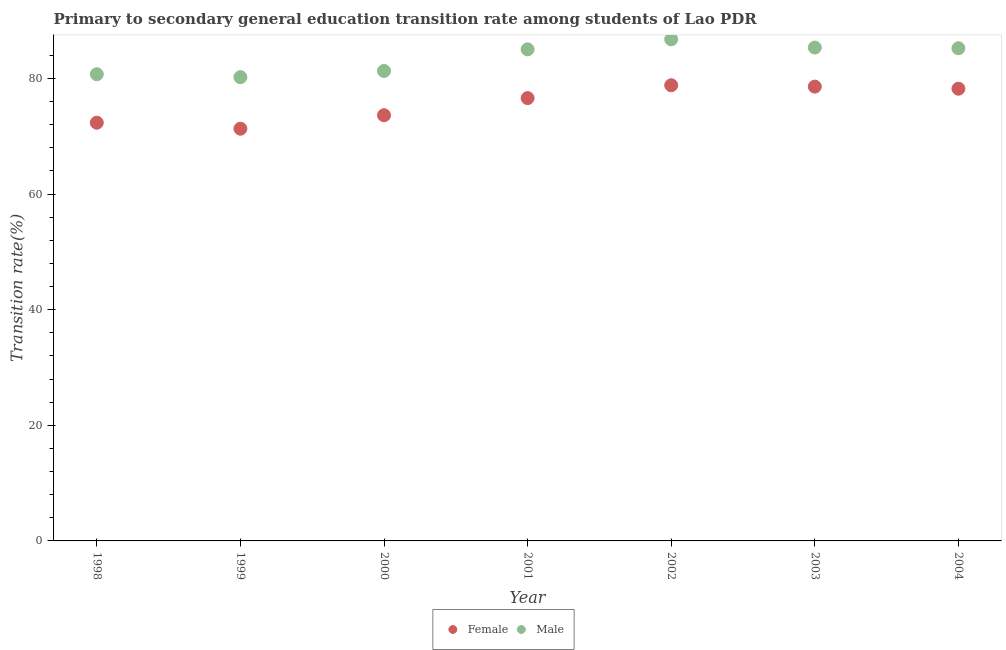Is the number of dotlines equal to the number of legend labels?
Offer a terse response. Yes. What is the transition rate among female students in 2001?
Your response must be concise. 76.6. Across all years, what is the maximum transition rate among male students?
Offer a very short reply. 86.76. Across all years, what is the minimum transition rate among male students?
Your answer should be compact. 80.22. What is the total transition rate among female students in the graph?
Offer a very short reply. 529.49. What is the difference between the transition rate among female students in 1999 and that in 2003?
Offer a terse response. -7.28. What is the difference between the transition rate among female students in 2000 and the transition rate among male students in 2004?
Your response must be concise. -11.59. What is the average transition rate among male students per year?
Your answer should be very brief. 83.51. In the year 2003, what is the difference between the transition rate among male students and transition rate among female students?
Provide a short and direct response. 6.76. In how many years, is the transition rate among male students greater than 48 %?
Make the answer very short. 7. What is the ratio of the transition rate among female students in 2001 to that in 2004?
Provide a succinct answer. 0.98. Is the transition rate among female students in 1998 less than that in 2002?
Your answer should be very brief. Yes. Is the difference between the transition rate among female students in 1998 and 2000 greater than the difference between the transition rate among male students in 1998 and 2000?
Your answer should be compact. No. What is the difference between the highest and the second highest transition rate among female students?
Provide a short and direct response. 0.24. What is the difference between the highest and the lowest transition rate among male students?
Offer a very short reply. 6.54. Is the sum of the transition rate among female students in 2001 and 2002 greater than the maximum transition rate among male students across all years?
Offer a very short reply. Yes. Is the transition rate among male students strictly less than the transition rate among female students over the years?
Ensure brevity in your answer.  No. How many dotlines are there?
Your response must be concise. 2. How many years are there in the graph?
Give a very brief answer. 7. What is the difference between two consecutive major ticks on the Y-axis?
Your response must be concise. 20. Does the graph contain grids?
Provide a succinct answer. No. Where does the legend appear in the graph?
Give a very brief answer. Bottom center. What is the title of the graph?
Your response must be concise. Primary to secondary general education transition rate among students of Lao PDR. Does "Diarrhea" appear as one of the legend labels in the graph?
Ensure brevity in your answer.  No. What is the label or title of the Y-axis?
Offer a very short reply. Transition rate(%). What is the Transition rate(%) of Female in 1998?
Make the answer very short. 72.34. What is the Transition rate(%) in Male in 1998?
Your answer should be very brief. 80.72. What is the Transition rate(%) of Female in 1999?
Offer a very short reply. 71.3. What is the Transition rate(%) in Male in 1999?
Keep it short and to the point. 80.22. What is the Transition rate(%) of Female in 2000?
Keep it short and to the point. 73.63. What is the Transition rate(%) in Male in 2000?
Make the answer very short. 81.3. What is the Transition rate(%) in Female in 2001?
Offer a terse response. 76.6. What is the Transition rate(%) in Male in 2001?
Keep it short and to the point. 85.03. What is the Transition rate(%) of Female in 2002?
Your answer should be very brief. 78.82. What is the Transition rate(%) in Male in 2002?
Offer a terse response. 86.76. What is the Transition rate(%) in Female in 2003?
Your answer should be compact. 78.58. What is the Transition rate(%) of Male in 2003?
Make the answer very short. 85.34. What is the Transition rate(%) in Female in 2004?
Give a very brief answer. 78.22. What is the Transition rate(%) of Male in 2004?
Keep it short and to the point. 85.22. Across all years, what is the maximum Transition rate(%) of Female?
Your answer should be very brief. 78.82. Across all years, what is the maximum Transition rate(%) of Male?
Your answer should be compact. 86.76. Across all years, what is the minimum Transition rate(%) of Female?
Your answer should be very brief. 71.3. Across all years, what is the minimum Transition rate(%) in Male?
Ensure brevity in your answer.  80.22. What is the total Transition rate(%) in Female in the graph?
Keep it short and to the point. 529.49. What is the total Transition rate(%) of Male in the graph?
Your response must be concise. 584.58. What is the difference between the Transition rate(%) of Female in 1998 and that in 1999?
Your answer should be compact. 1.04. What is the difference between the Transition rate(%) in Male in 1998 and that in 1999?
Your answer should be compact. 0.51. What is the difference between the Transition rate(%) in Female in 1998 and that in 2000?
Your answer should be very brief. -1.29. What is the difference between the Transition rate(%) of Male in 1998 and that in 2000?
Make the answer very short. -0.57. What is the difference between the Transition rate(%) of Female in 1998 and that in 2001?
Your answer should be compact. -4.26. What is the difference between the Transition rate(%) of Male in 1998 and that in 2001?
Provide a succinct answer. -4.3. What is the difference between the Transition rate(%) in Female in 1998 and that in 2002?
Your response must be concise. -6.48. What is the difference between the Transition rate(%) of Male in 1998 and that in 2002?
Your response must be concise. -6.03. What is the difference between the Transition rate(%) of Female in 1998 and that in 2003?
Ensure brevity in your answer.  -6.25. What is the difference between the Transition rate(%) in Male in 1998 and that in 2003?
Your response must be concise. -4.61. What is the difference between the Transition rate(%) of Female in 1998 and that in 2004?
Keep it short and to the point. -5.88. What is the difference between the Transition rate(%) of Male in 1998 and that in 2004?
Your response must be concise. -4.5. What is the difference between the Transition rate(%) in Female in 1999 and that in 2000?
Your answer should be very brief. -2.33. What is the difference between the Transition rate(%) in Male in 1999 and that in 2000?
Your response must be concise. -1.08. What is the difference between the Transition rate(%) of Female in 1999 and that in 2001?
Provide a succinct answer. -5.3. What is the difference between the Transition rate(%) in Male in 1999 and that in 2001?
Your answer should be very brief. -4.81. What is the difference between the Transition rate(%) in Female in 1999 and that in 2002?
Your answer should be compact. -7.52. What is the difference between the Transition rate(%) of Male in 1999 and that in 2002?
Offer a very short reply. -6.54. What is the difference between the Transition rate(%) of Female in 1999 and that in 2003?
Your answer should be very brief. -7.28. What is the difference between the Transition rate(%) in Male in 1999 and that in 2003?
Make the answer very short. -5.12. What is the difference between the Transition rate(%) of Female in 1999 and that in 2004?
Ensure brevity in your answer.  -6.92. What is the difference between the Transition rate(%) in Male in 1999 and that in 2004?
Your answer should be compact. -5. What is the difference between the Transition rate(%) of Female in 2000 and that in 2001?
Provide a succinct answer. -2.97. What is the difference between the Transition rate(%) in Male in 2000 and that in 2001?
Your response must be concise. -3.73. What is the difference between the Transition rate(%) in Female in 2000 and that in 2002?
Give a very brief answer. -5.19. What is the difference between the Transition rate(%) in Male in 2000 and that in 2002?
Provide a short and direct response. -5.46. What is the difference between the Transition rate(%) in Female in 2000 and that in 2003?
Keep it short and to the point. -4.95. What is the difference between the Transition rate(%) of Male in 2000 and that in 2003?
Give a very brief answer. -4.04. What is the difference between the Transition rate(%) in Female in 2000 and that in 2004?
Provide a succinct answer. -4.59. What is the difference between the Transition rate(%) of Male in 2000 and that in 2004?
Ensure brevity in your answer.  -3.92. What is the difference between the Transition rate(%) in Female in 2001 and that in 2002?
Your response must be concise. -2.22. What is the difference between the Transition rate(%) in Male in 2001 and that in 2002?
Offer a terse response. -1.73. What is the difference between the Transition rate(%) in Female in 2001 and that in 2003?
Your response must be concise. -1.99. What is the difference between the Transition rate(%) in Male in 2001 and that in 2003?
Offer a very short reply. -0.31. What is the difference between the Transition rate(%) in Female in 2001 and that in 2004?
Your answer should be compact. -1.62. What is the difference between the Transition rate(%) of Male in 2001 and that in 2004?
Your response must be concise. -0.19. What is the difference between the Transition rate(%) of Female in 2002 and that in 2003?
Offer a terse response. 0.24. What is the difference between the Transition rate(%) in Male in 2002 and that in 2003?
Provide a short and direct response. 1.42. What is the difference between the Transition rate(%) in Female in 2002 and that in 2004?
Your response must be concise. 0.6. What is the difference between the Transition rate(%) in Male in 2002 and that in 2004?
Offer a terse response. 1.54. What is the difference between the Transition rate(%) of Female in 2003 and that in 2004?
Your answer should be compact. 0.36. What is the difference between the Transition rate(%) in Male in 2003 and that in 2004?
Offer a terse response. 0.12. What is the difference between the Transition rate(%) of Female in 1998 and the Transition rate(%) of Male in 1999?
Your response must be concise. -7.88. What is the difference between the Transition rate(%) in Female in 1998 and the Transition rate(%) in Male in 2000?
Keep it short and to the point. -8.96. What is the difference between the Transition rate(%) in Female in 1998 and the Transition rate(%) in Male in 2001?
Provide a succinct answer. -12.69. What is the difference between the Transition rate(%) of Female in 1998 and the Transition rate(%) of Male in 2002?
Provide a succinct answer. -14.42. What is the difference between the Transition rate(%) of Female in 1998 and the Transition rate(%) of Male in 2003?
Offer a terse response. -13. What is the difference between the Transition rate(%) of Female in 1998 and the Transition rate(%) of Male in 2004?
Your answer should be very brief. -12.88. What is the difference between the Transition rate(%) in Female in 1999 and the Transition rate(%) in Male in 2000?
Offer a very short reply. -10. What is the difference between the Transition rate(%) in Female in 1999 and the Transition rate(%) in Male in 2001?
Provide a short and direct response. -13.73. What is the difference between the Transition rate(%) of Female in 1999 and the Transition rate(%) of Male in 2002?
Provide a short and direct response. -15.46. What is the difference between the Transition rate(%) of Female in 1999 and the Transition rate(%) of Male in 2003?
Make the answer very short. -14.04. What is the difference between the Transition rate(%) in Female in 1999 and the Transition rate(%) in Male in 2004?
Provide a succinct answer. -13.92. What is the difference between the Transition rate(%) in Female in 2000 and the Transition rate(%) in Male in 2001?
Offer a very short reply. -11.4. What is the difference between the Transition rate(%) in Female in 2000 and the Transition rate(%) in Male in 2002?
Your answer should be very brief. -13.13. What is the difference between the Transition rate(%) of Female in 2000 and the Transition rate(%) of Male in 2003?
Your answer should be very brief. -11.71. What is the difference between the Transition rate(%) of Female in 2000 and the Transition rate(%) of Male in 2004?
Keep it short and to the point. -11.59. What is the difference between the Transition rate(%) in Female in 2001 and the Transition rate(%) in Male in 2002?
Provide a short and direct response. -10.16. What is the difference between the Transition rate(%) in Female in 2001 and the Transition rate(%) in Male in 2003?
Keep it short and to the point. -8.74. What is the difference between the Transition rate(%) in Female in 2001 and the Transition rate(%) in Male in 2004?
Your answer should be compact. -8.62. What is the difference between the Transition rate(%) in Female in 2002 and the Transition rate(%) in Male in 2003?
Provide a short and direct response. -6.52. What is the difference between the Transition rate(%) of Female in 2002 and the Transition rate(%) of Male in 2004?
Ensure brevity in your answer.  -6.4. What is the difference between the Transition rate(%) in Female in 2003 and the Transition rate(%) in Male in 2004?
Ensure brevity in your answer.  -6.64. What is the average Transition rate(%) of Female per year?
Provide a succinct answer. 75.64. What is the average Transition rate(%) of Male per year?
Your response must be concise. 83.51. In the year 1998, what is the difference between the Transition rate(%) of Female and Transition rate(%) of Male?
Keep it short and to the point. -8.39. In the year 1999, what is the difference between the Transition rate(%) of Female and Transition rate(%) of Male?
Offer a very short reply. -8.92. In the year 2000, what is the difference between the Transition rate(%) of Female and Transition rate(%) of Male?
Offer a terse response. -7.66. In the year 2001, what is the difference between the Transition rate(%) of Female and Transition rate(%) of Male?
Your response must be concise. -8.43. In the year 2002, what is the difference between the Transition rate(%) of Female and Transition rate(%) of Male?
Keep it short and to the point. -7.94. In the year 2003, what is the difference between the Transition rate(%) of Female and Transition rate(%) of Male?
Your answer should be compact. -6.76. In the year 2004, what is the difference between the Transition rate(%) in Female and Transition rate(%) in Male?
Keep it short and to the point. -7. What is the ratio of the Transition rate(%) in Female in 1998 to that in 1999?
Offer a very short reply. 1.01. What is the ratio of the Transition rate(%) in Female in 1998 to that in 2000?
Give a very brief answer. 0.98. What is the ratio of the Transition rate(%) in Male in 1998 to that in 2000?
Give a very brief answer. 0.99. What is the ratio of the Transition rate(%) in Male in 1998 to that in 2001?
Your response must be concise. 0.95. What is the ratio of the Transition rate(%) in Female in 1998 to that in 2002?
Provide a succinct answer. 0.92. What is the ratio of the Transition rate(%) in Male in 1998 to that in 2002?
Provide a short and direct response. 0.93. What is the ratio of the Transition rate(%) of Female in 1998 to that in 2003?
Give a very brief answer. 0.92. What is the ratio of the Transition rate(%) of Male in 1998 to that in 2003?
Provide a short and direct response. 0.95. What is the ratio of the Transition rate(%) of Female in 1998 to that in 2004?
Your response must be concise. 0.92. What is the ratio of the Transition rate(%) in Male in 1998 to that in 2004?
Your response must be concise. 0.95. What is the ratio of the Transition rate(%) in Female in 1999 to that in 2000?
Offer a very short reply. 0.97. What is the ratio of the Transition rate(%) in Male in 1999 to that in 2000?
Ensure brevity in your answer.  0.99. What is the ratio of the Transition rate(%) of Female in 1999 to that in 2001?
Make the answer very short. 0.93. What is the ratio of the Transition rate(%) in Male in 1999 to that in 2001?
Give a very brief answer. 0.94. What is the ratio of the Transition rate(%) in Female in 1999 to that in 2002?
Offer a terse response. 0.9. What is the ratio of the Transition rate(%) in Male in 1999 to that in 2002?
Offer a terse response. 0.92. What is the ratio of the Transition rate(%) in Female in 1999 to that in 2003?
Ensure brevity in your answer.  0.91. What is the ratio of the Transition rate(%) in Male in 1999 to that in 2003?
Your answer should be compact. 0.94. What is the ratio of the Transition rate(%) in Female in 1999 to that in 2004?
Ensure brevity in your answer.  0.91. What is the ratio of the Transition rate(%) of Male in 1999 to that in 2004?
Your response must be concise. 0.94. What is the ratio of the Transition rate(%) of Female in 2000 to that in 2001?
Provide a short and direct response. 0.96. What is the ratio of the Transition rate(%) in Male in 2000 to that in 2001?
Provide a succinct answer. 0.96. What is the ratio of the Transition rate(%) of Female in 2000 to that in 2002?
Make the answer very short. 0.93. What is the ratio of the Transition rate(%) in Male in 2000 to that in 2002?
Your response must be concise. 0.94. What is the ratio of the Transition rate(%) in Female in 2000 to that in 2003?
Offer a very short reply. 0.94. What is the ratio of the Transition rate(%) of Male in 2000 to that in 2003?
Ensure brevity in your answer.  0.95. What is the ratio of the Transition rate(%) of Female in 2000 to that in 2004?
Offer a very short reply. 0.94. What is the ratio of the Transition rate(%) of Male in 2000 to that in 2004?
Provide a succinct answer. 0.95. What is the ratio of the Transition rate(%) in Female in 2001 to that in 2002?
Your answer should be compact. 0.97. What is the ratio of the Transition rate(%) in Male in 2001 to that in 2002?
Your response must be concise. 0.98. What is the ratio of the Transition rate(%) in Female in 2001 to that in 2003?
Your answer should be compact. 0.97. What is the ratio of the Transition rate(%) of Female in 2001 to that in 2004?
Keep it short and to the point. 0.98. What is the ratio of the Transition rate(%) in Female in 2002 to that in 2003?
Ensure brevity in your answer.  1. What is the ratio of the Transition rate(%) of Male in 2002 to that in 2003?
Keep it short and to the point. 1.02. What is the ratio of the Transition rate(%) of Female in 2002 to that in 2004?
Provide a short and direct response. 1.01. What is the ratio of the Transition rate(%) of Male in 2002 to that in 2004?
Ensure brevity in your answer.  1.02. What is the ratio of the Transition rate(%) of Female in 2003 to that in 2004?
Provide a short and direct response. 1. What is the difference between the highest and the second highest Transition rate(%) in Female?
Your response must be concise. 0.24. What is the difference between the highest and the second highest Transition rate(%) of Male?
Keep it short and to the point. 1.42. What is the difference between the highest and the lowest Transition rate(%) in Female?
Provide a short and direct response. 7.52. What is the difference between the highest and the lowest Transition rate(%) of Male?
Make the answer very short. 6.54. 